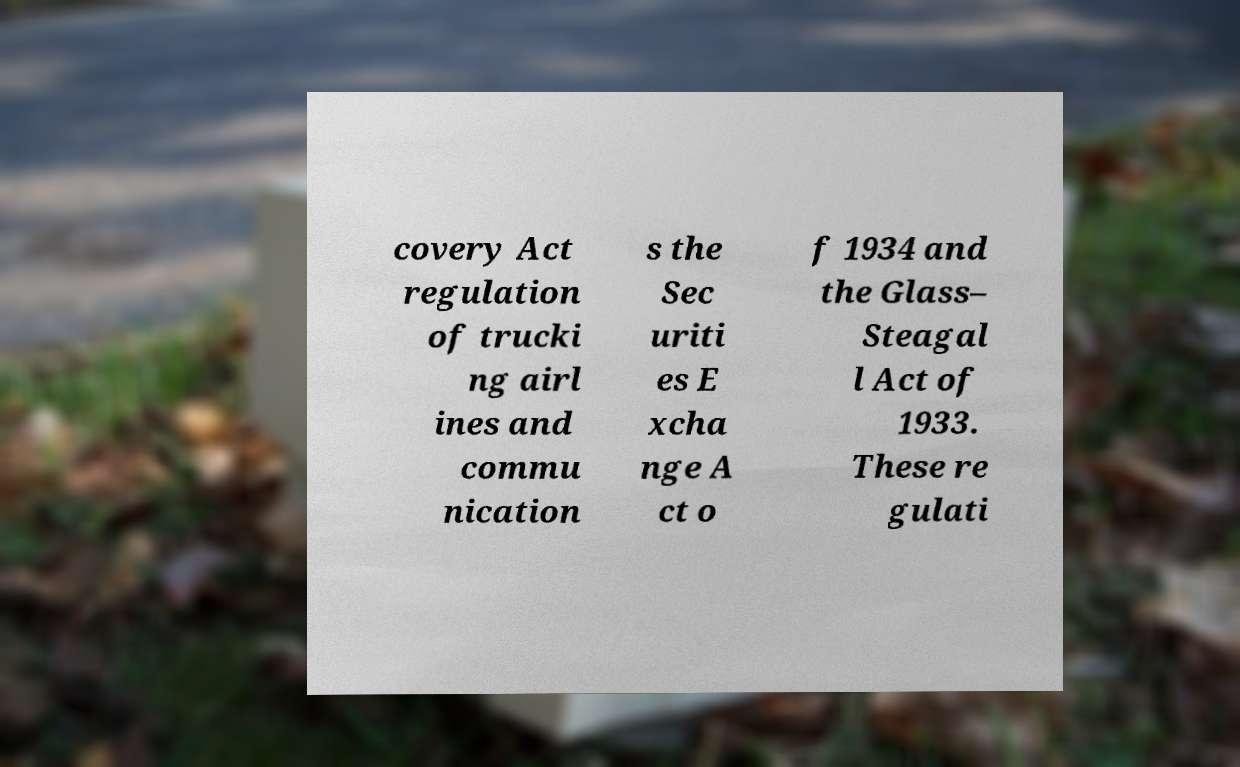For documentation purposes, I need the text within this image transcribed. Could you provide that? covery Act regulation of trucki ng airl ines and commu nication s the Sec uriti es E xcha nge A ct o f 1934 and the Glass– Steagal l Act of 1933. These re gulati 